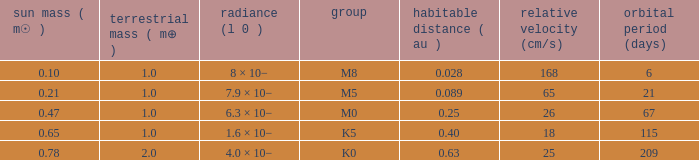What is the total stellar mass of the type m0? 0.47. 